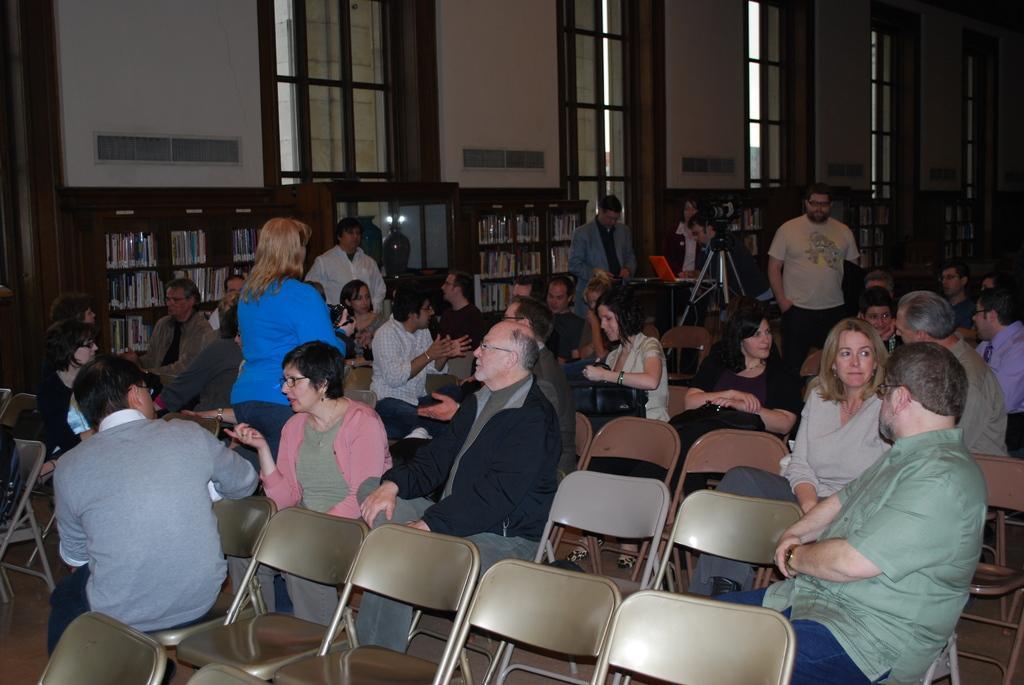How would you summarize this image in a sentence or two? In this picture we can see some persons are sitting on the chairs. And even we can see some persons are standing on the floor. This is the wall and there is a rack. We can see some books in the rack. And this is the door. 